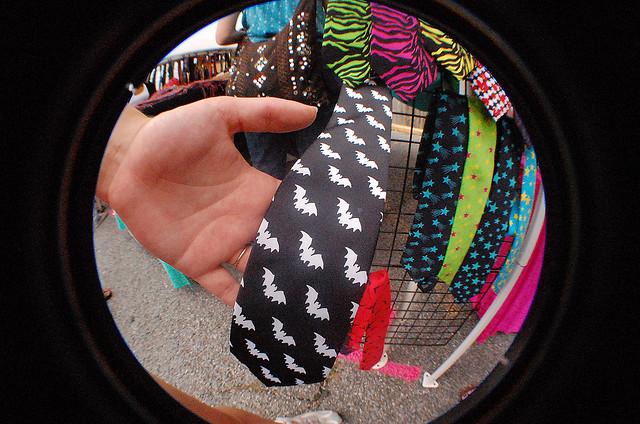How many colors are present?
Keep it brief. 10. What is this item?
Give a very brief answer. Tie. How many ties are shown?
Be succinct. 10. 